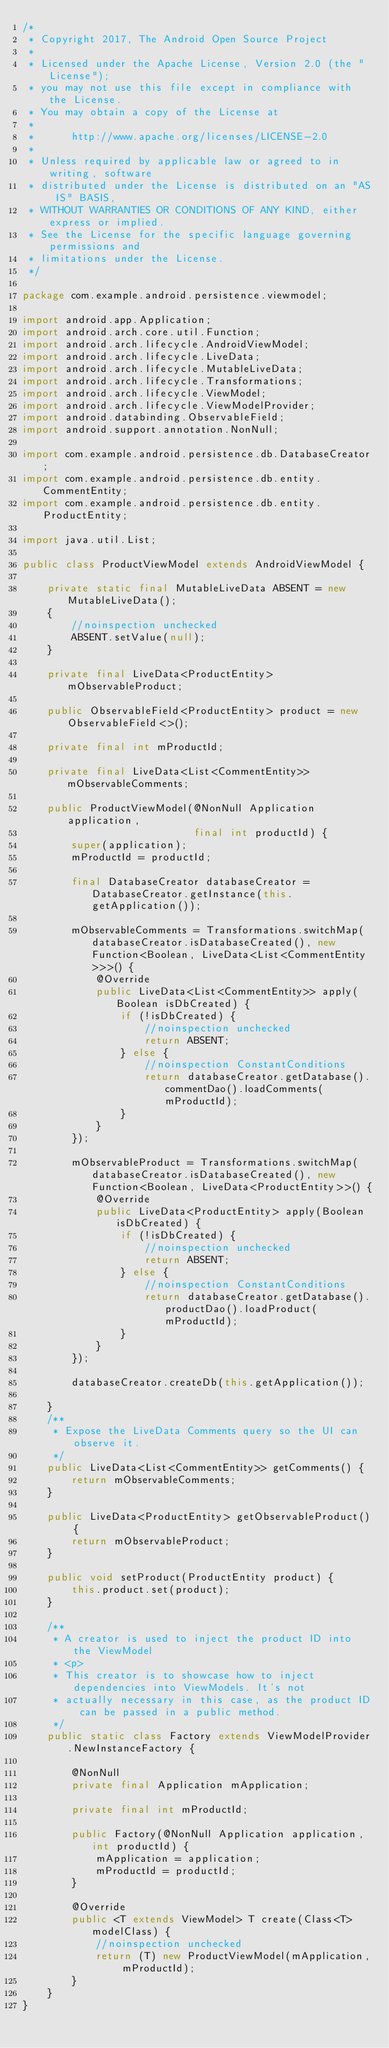Convert code to text. <code><loc_0><loc_0><loc_500><loc_500><_Java_>/*
 * Copyright 2017, The Android Open Source Project
 *
 * Licensed under the Apache License, Version 2.0 (the "License");
 * you may not use this file except in compliance with the License.
 * You may obtain a copy of the License at
 *
 *      http://www.apache.org/licenses/LICENSE-2.0
 *
 * Unless required by applicable law or agreed to in writing, software
 * distributed under the License is distributed on an "AS IS" BASIS,
 * WITHOUT WARRANTIES OR CONDITIONS OF ANY KIND, either express or implied.
 * See the License for the specific language governing permissions and
 * limitations under the License.
 */

package com.example.android.persistence.viewmodel;

import android.app.Application;
import android.arch.core.util.Function;
import android.arch.lifecycle.AndroidViewModel;
import android.arch.lifecycle.LiveData;
import android.arch.lifecycle.MutableLiveData;
import android.arch.lifecycle.Transformations;
import android.arch.lifecycle.ViewModel;
import android.arch.lifecycle.ViewModelProvider;
import android.databinding.ObservableField;
import android.support.annotation.NonNull;

import com.example.android.persistence.db.DatabaseCreator;
import com.example.android.persistence.db.entity.CommentEntity;
import com.example.android.persistence.db.entity.ProductEntity;

import java.util.List;

public class ProductViewModel extends AndroidViewModel {

    private static final MutableLiveData ABSENT = new MutableLiveData();
    {
        //noinspection unchecked
        ABSENT.setValue(null);
    }

    private final LiveData<ProductEntity> mObservableProduct;

    public ObservableField<ProductEntity> product = new ObservableField<>();

    private final int mProductId;

    private final LiveData<List<CommentEntity>> mObservableComments;

    public ProductViewModel(@NonNull Application application,
                            final int productId) {
        super(application);
        mProductId = productId;

        final DatabaseCreator databaseCreator = DatabaseCreator.getInstance(this.getApplication());

        mObservableComments = Transformations.switchMap(databaseCreator.isDatabaseCreated(), new Function<Boolean, LiveData<List<CommentEntity>>>() {
            @Override
            public LiveData<List<CommentEntity>> apply(Boolean isDbCreated) {
                if (!isDbCreated) {
                    //noinspection unchecked
                    return ABSENT;
                } else {
                    //noinspection ConstantConditions
                    return databaseCreator.getDatabase().commentDao().loadComments(mProductId);
                }
            }
        });

        mObservableProduct = Transformations.switchMap(databaseCreator.isDatabaseCreated(), new Function<Boolean, LiveData<ProductEntity>>() {
            @Override
            public LiveData<ProductEntity> apply(Boolean isDbCreated) {
                if (!isDbCreated) {
                    //noinspection unchecked
                    return ABSENT;
                } else {
                    //noinspection ConstantConditions
                    return databaseCreator.getDatabase().productDao().loadProduct(mProductId);
                }
            }
        });

        databaseCreator.createDb(this.getApplication());

    }
    /**
     * Expose the LiveData Comments query so the UI can observe it.
     */
    public LiveData<List<CommentEntity>> getComments() {
        return mObservableComments;
    }

    public LiveData<ProductEntity> getObservableProduct() {
        return mObservableProduct;
    }

    public void setProduct(ProductEntity product) {
        this.product.set(product);
    }

    /**
     * A creator is used to inject the product ID into the ViewModel
     * <p>
     * This creator is to showcase how to inject dependencies into ViewModels. It's not
     * actually necessary in this case, as the product ID can be passed in a public method.
     */
    public static class Factory extends ViewModelProvider.NewInstanceFactory {

        @NonNull
        private final Application mApplication;

        private final int mProductId;

        public Factory(@NonNull Application application, int productId) {
            mApplication = application;
            mProductId = productId;
        }

        @Override
        public <T extends ViewModel> T create(Class<T> modelClass) {
            //noinspection unchecked
            return (T) new ProductViewModel(mApplication, mProductId);
        }
    }
}
</code> 